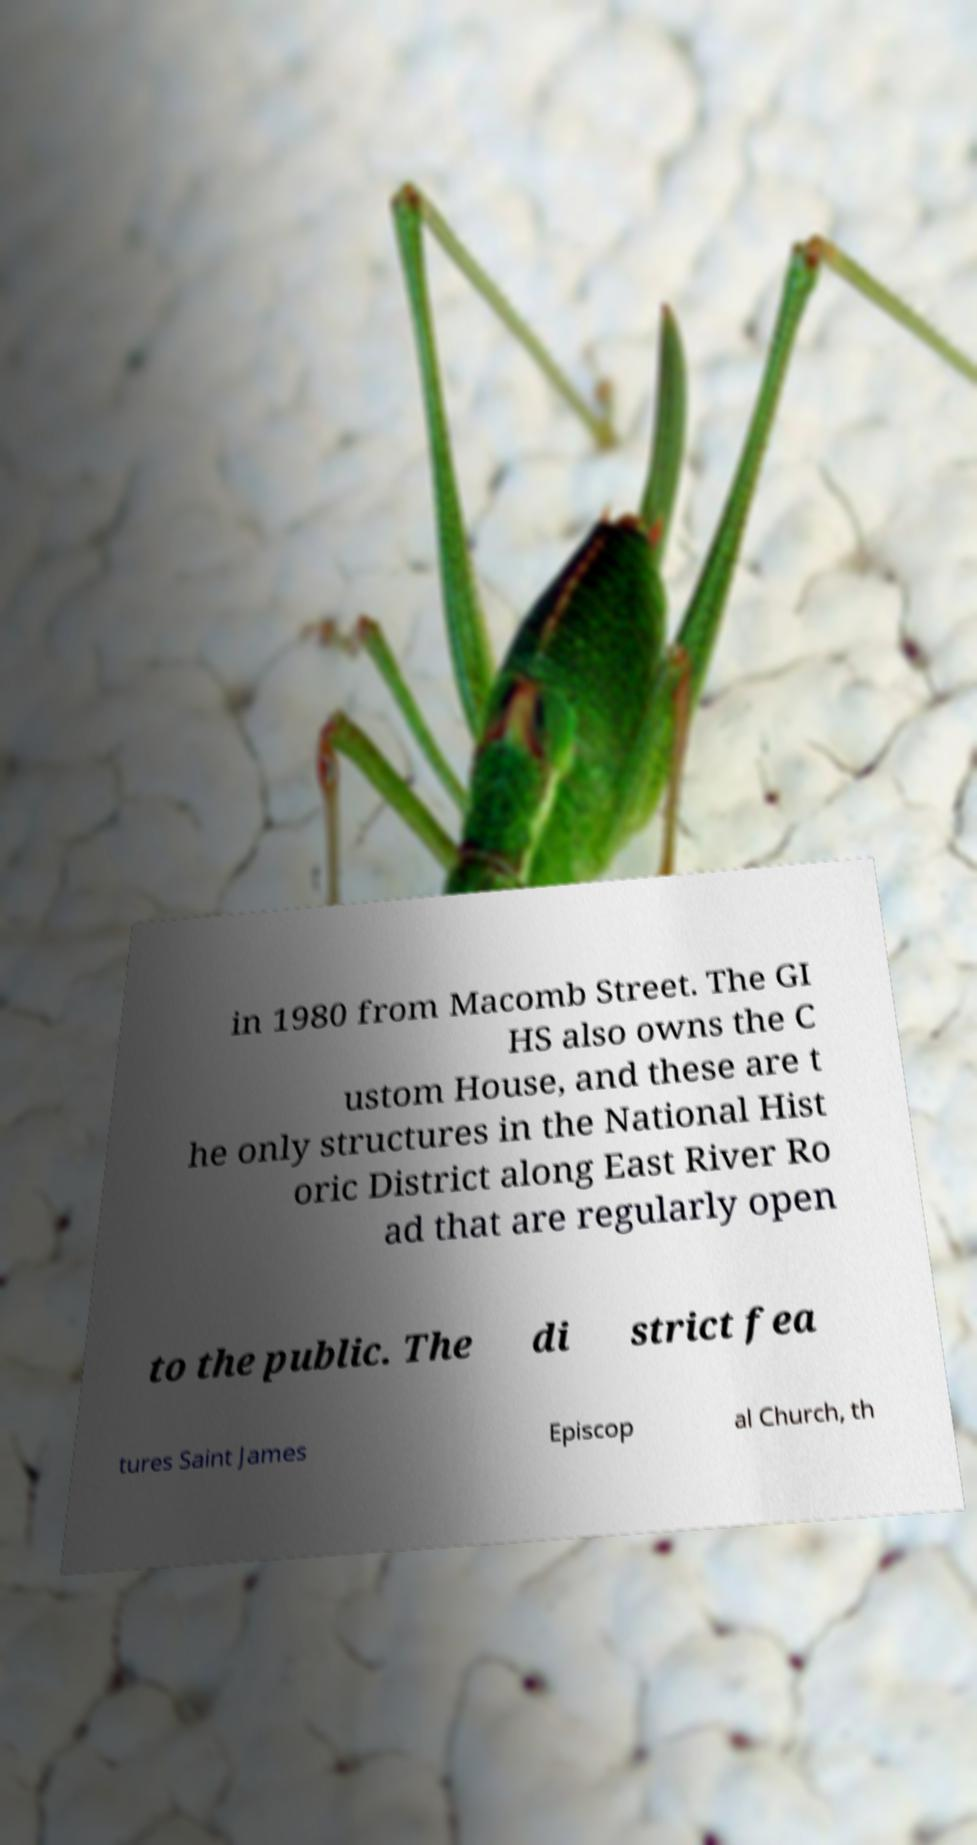Please identify and transcribe the text found in this image. in 1980 from Macomb Street. The GI HS also owns the C ustom House, and these are t he only structures in the National Hist oric District along East River Ro ad that are regularly open to the public. The di strict fea tures Saint James Episcop al Church, th 